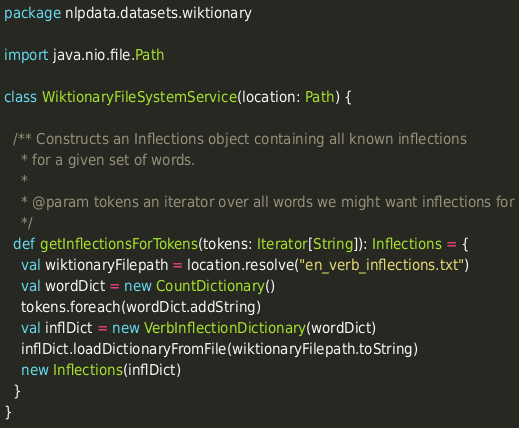Convert code to text. <code><loc_0><loc_0><loc_500><loc_500><_Scala_>package nlpdata.datasets.wiktionary

import java.nio.file.Path

class WiktionaryFileSystemService(location: Path) {

  /** Constructs an Inflections object containing all known inflections
    * for a given set of words.
    *
    * @param tokens an iterator over all words we might want inflections for
    */
  def getInflectionsForTokens(tokens: Iterator[String]): Inflections = {
    val wiktionaryFilepath = location.resolve("en_verb_inflections.txt")
    val wordDict = new CountDictionary()
    tokens.foreach(wordDict.addString)
    val inflDict = new VerbInflectionDictionary(wordDict)
    inflDict.loadDictionaryFromFile(wiktionaryFilepath.toString)
    new Inflections(inflDict)
  }
}
</code> 